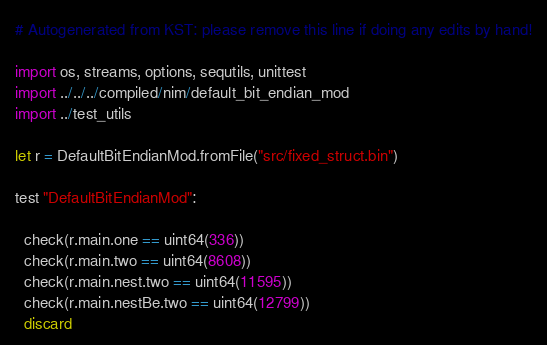Convert code to text. <code><loc_0><loc_0><loc_500><loc_500><_Nim_># Autogenerated from KST: please remove this line if doing any edits by hand!

import os, streams, options, sequtils, unittest
import ../../../compiled/nim/default_bit_endian_mod
import ../test_utils

let r = DefaultBitEndianMod.fromFile("src/fixed_struct.bin")

test "DefaultBitEndianMod":

  check(r.main.one == uint64(336))
  check(r.main.two == uint64(8608))
  check(r.main.nest.two == uint64(11595))
  check(r.main.nestBe.two == uint64(12799))
  discard
</code> 